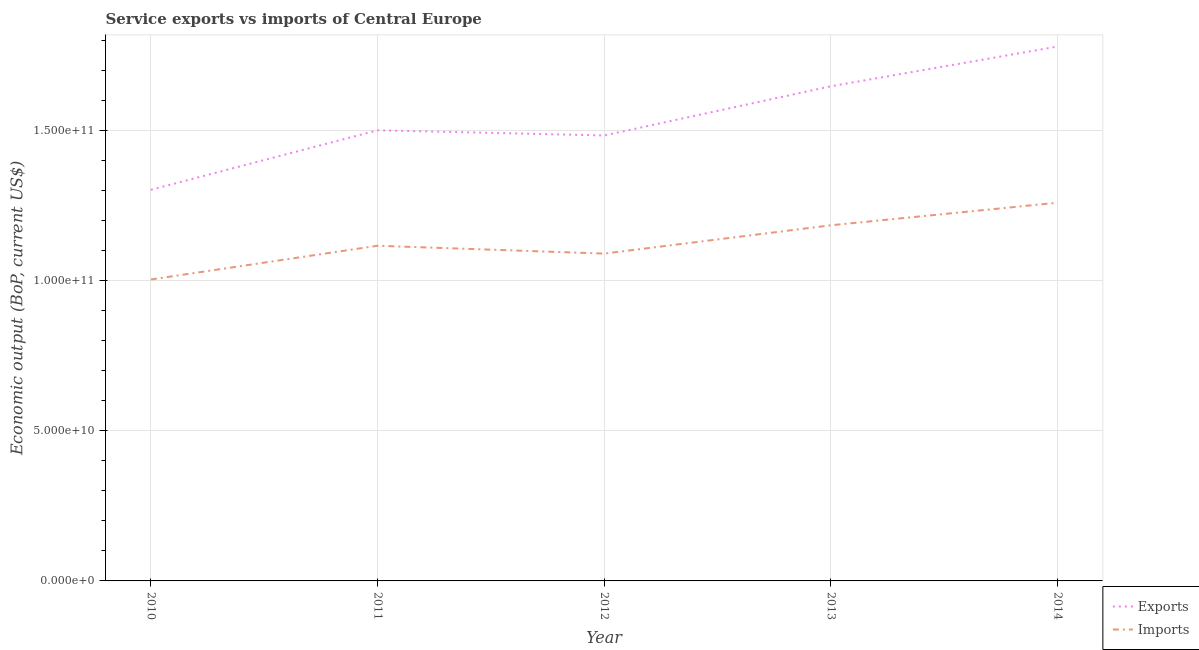Does the line corresponding to amount of service exports intersect with the line corresponding to amount of service imports?
Your response must be concise. No. What is the amount of service exports in 2012?
Make the answer very short. 1.48e+11. Across all years, what is the maximum amount of service imports?
Offer a very short reply. 1.26e+11. Across all years, what is the minimum amount of service exports?
Provide a short and direct response. 1.30e+11. In which year was the amount of service imports maximum?
Provide a short and direct response. 2014. What is the total amount of service exports in the graph?
Keep it short and to the point. 7.71e+11. What is the difference between the amount of service exports in 2012 and that in 2013?
Your answer should be very brief. -1.64e+1. What is the difference between the amount of service imports in 2013 and the amount of service exports in 2010?
Ensure brevity in your answer.  -1.18e+1. What is the average amount of service imports per year?
Make the answer very short. 1.13e+11. In the year 2010, what is the difference between the amount of service exports and amount of service imports?
Make the answer very short. 2.99e+1. In how many years, is the amount of service imports greater than 50000000000 US$?
Your answer should be very brief. 5. What is the ratio of the amount of service exports in 2010 to that in 2011?
Provide a short and direct response. 0.87. What is the difference between the highest and the second highest amount of service exports?
Ensure brevity in your answer.  1.32e+1. What is the difference between the highest and the lowest amount of service exports?
Make the answer very short. 4.77e+1. Is the sum of the amount of service imports in 2010 and 2013 greater than the maximum amount of service exports across all years?
Keep it short and to the point. Yes. How many years are there in the graph?
Your answer should be compact. 5. Are the values on the major ticks of Y-axis written in scientific E-notation?
Offer a terse response. Yes. Where does the legend appear in the graph?
Your answer should be very brief. Bottom right. What is the title of the graph?
Ensure brevity in your answer.  Service exports vs imports of Central Europe. What is the label or title of the X-axis?
Your response must be concise. Year. What is the label or title of the Y-axis?
Offer a terse response. Economic output (BoP, current US$). What is the Economic output (BoP, current US$) of Exports in 2010?
Make the answer very short. 1.30e+11. What is the Economic output (BoP, current US$) in Imports in 2010?
Offer a terse response. 1.00e+11. What is the Economic output (BoP, current US$) in Exports in 2011?
Ensure brevity in your answer.  1.50e+11. What is the Economic output (BoP, current US$) of Imports in 2011?
Provide a succinct answer. 1.12e+11. What is the Economic output (BoP, current US$) in Exports in 2012?
Your response must be concise. 1.48e+11. What is the Economic output (BoP, current US$) in Imports in 2012?
Your response must be concise. 1.09e+11. What is the Economic output (BoP, current US$) of Exports in 2013?
Your answer should be compact. 1.65e+11. What is the Economic output (BoP, current US$) of Imports in 2013?
Offer a terse response. 1.18e+11. What is the Economic output (BoP, current US$) of Exports in 2014?
Make the answer very short. 1.78e+11. What is the Economic output (BoP, current US$) of Imports in 2014?
Your answer should be very brief. 1.26e+11. Across all years, what is the maximum Economic output (BoP, current US$) in Exports?
Your answer should be very brief. 1.78e+11. Across all years, what is the maximum Economic output (BoP, current US$) in Imports?
Provide a succinct answer. 1.26e+11. Across all years, what is the minimum Economic output (BoP, current US$) in Exports?
Offer a very short reply. 1.30e+11. Across all years, what is the minimum Economic output (BoP, current US$) of Imports?
Offer a very short reply. 1.00e+11. What is the total Economic output (BoP, current US$) of Exports in the graph?
Offer a very short reply. 7.71e+11. What is the total Economic output (BoP, current US$) of Imports in the graph?
Make the answer very short. 5.65e+11. What is the difference between the Economic output (BoP, current US$) of Exports in 2010 and that in 2011?
Ensure brevity in your answer.  -1.98e+1. What is the difference between the Economic output (BoP, current US$) of Imports in 2010 and that in 2011?
Give a very brief answer. -1.12e+1. What is the difference between the Economic output (BoP, current US$) in Exports in 2010 and that in 2012?
Provide a succinct answer. -1.81e+1. What is the difference between the Economic output (BoP, current US$) in Imports in 2010 and that in 2012?
Keep it short and to the point. -8.62e+09. What is the difference between the Economic output (BoP, current US$) of Exports in 2010 and that in 2013?
Offer a terse response. -3.45e+1. What is the difference between the Economic output (BoP, current US$) in Imports in 2010 and that in 2013?
Ensure brevity in your answer.  -1.80e+1. What is the difference between the Economic output (BoP, current US$) of Exports in 2010 and that in 2014?
Provide a short and direct response. -4.77e+1. What is the difference between the Economic output (BoP, current US$) in Imports in 2010 and that in 2014?
Ensure brevity in your answer.  -2.56e+1. What is the difference between the Economic output (BoP, current US$) in Exports in 2011 and that in 2012?
Provide a short and direct response. 1.72e+09. What is the difference between the Economic output (BoP, current US$) of Imports in 2011 and that in 2012?
Your response must be concise. 2.61e+09. What is the difference between the Economic output (BoP, current US$) of Exports in 2011 and that in 2013?
Ensure brevity in your answer.  -1.47e+1. What is the difference between the Economic output (BoP, current US$) of Imports in 2011 and that in 2013?
Keep it short and to the point. -6.81e+09. What is the difference between the Economic output (BoP, current US$) of Exports in 2011 and that in 2014?
Your response must be concise. -2.79e+1. What is the difference between the Economic output (BoP, current US$) of Imports in 2011 and that in 2014?
Give a very brief answer. -1.43e+1. What is the difference between the Economic output (BoP, current US$) in Exports in 2012 and that in 2013?
Provide a short and direct response. -1.64e+1. What is the difference between the Economic output (BoP, current US$) of Imports in 2012 and that in 2013?
Keep it short and to the point. -9.42e+09. What is the difference between the Economic output (BoP, current US$) in Exports in 2012 and that in 2014?
Ensure brevity in your answer.  -2.96e+1. What is the difference between the Economic output (BoP, current US$) of Imports in 2012 and that in 2014?
Your answer should be very brief. -1.69e+1. What is the difference between the Economic output (BoP, current US$) in Exports in 2013 and that in 2014?
Ensure brevity in your answer.  -1.32e+1. What is the difference between the Economic output (BoP, current US$) in Imports in 2013 and that in 2014?
Make the answer very short. -7.52e+09. What is the difference between the Economic output (BoP, current US$) in Exports in 2010 and the Economic output (BoP, current US$) in Imports in 2011?
Offer a terse response. 1.86e+1. What is the difference between the Economic output (BoP, current US$) in Exports in 2010 and the Economic output (BoP, current US$) in Imports in 2012?
Make the answer very short. 2.12e+1. What is the difference between the Economic output (BoP, current US$) in Exports in 2010 and the Economic output (BoP, current US$) in Imports in 2013?
Keep it short and to the point. 1.18e+1. What is the difference between the Economic output (BoP, current US$) of Exports in 2010 and the Economic output (BoP, current US$) of Imports in 2014?
Provide a short and direct response. 4.30e+09. What is the difference between the Economic output (BoP, current US$) in Exports in 2011 and the Economic output (BoP, current US$) in Imports in 2012?
Provide a short and direct response. 4.10e+1. What is the difference between the Economic output (BoP, current US$) of Exports in 2011 and the Economic output (BoP, current US$) of Imports in 2013?
Ensure brevity in your answer.  3.16e+1. What is the difference between the Economic output (BoP, current US$) in Exports in 2011 and the Economic output (BoP, current US$) in Imports in 2014?
Your response must be concise. 2.41e+1. What is the difference between the Economic output (BoP, current US$) in Exports in 2012 and the Economic output (BoP, current US$) in Imports in 2013?
Offer a terse response. 2.99e+1. What is the difference between the Economic output (BoP, current US$) of Exports in 2012 and the Economic output (BoP, current US$) of Imports in 2014?
Provide a short and direct response. 2.24e+1. What is the difference between the Economic output (BoP, current US$) of Exports in 2013 and the Economic output (BoP, current US$) of Imports in 2014?
Your answer should be very brief. 3.88e+1. What is the average Economic output (BoP, current US$) of Exports per year?
Ensure brevity in your answer.  1.54e+11. What is the average Economic output (BoP, current US$) in Imports per year?
Provide a succinct answer. 1.13e+11. In the year 2010, what is the difference between the Economic output (BoP, current US$) of Exports and Economic output (BoP, current US$) of Imports?
Give a very brief answer. 2.99e+1. In the year 2011, what is the difference between the Economic output (BoP, current US$) of Exports and Economic output (BoP, current US$) of Imports?
Your answer should be compact. 3.84e+1. In the year 2012, what is the difference between the Economic output (BoP, current US$) in Exports and Economic output (BoP, current US$) in Imports?
Give a very brief answer. 3.93e+1. In the year 2013, what is the difference between the Economic output (BoP, current US$) of Exports and Economic output (BoP, current US$) of Imports?
Your answer should be compact. 4.63e+1. In the year 2014, what is the difference between the Economic output (BoP, current US$) of Exports and Economic output (BoP, current US$) of Imports?
Make the answer very short. 5.20e+1. What is the ratio of the Economic output (BoP, current US$) of Exports in 2010 to that in 2011?
Provide a short and direct response. 0.87. What is the ratio of the Economic output (BoP, current US$) of Imports in 2010 to that in 2011?
Provide a succinct answer. 0.9. What is the ratio of the Economic output (BoP, current US$) in Exports in 2010 to that in 2012?
Your response must be concise. 0.88. What is the ratio of the Economic output (BoP, current US$) in Imports in 2010 to that in 2012?
Keep it short and to the point. 0.92. What is the ratio of the Economic output (BoP, current US$) in Exports in 2010 to that in 2013?
Your answer should be very brief. 0.79. What is the ratio of the Economic output (BoP, current US$) in Imports in 2010 to that in 2013?
Your answer should be very brief. 0.85. What is the ratio of the Economic output (BoP, current US$) of Exports in 2010 to that in 2014?
Your answer should be very brief. 0.73. What is the ratio of the Economic output (BoP, current US$) of Imports in 2010 to that in 2014?
Your response must be concise. 0.8. What is the ratio of the Economic output (BoP, current US$) of Exports in 2011 to that in 2012?
Offer a very short reply. 1.01. What is the ratio of the Economic output (BoP, current US$) in Imports in 2011 to that in 2012?
Your answer should be compact. 1.02. What is the ratio of the Economic output (BoP, current US$) in Exports in 2011 to that in 2013?
Offer a very short reply. 0.91. What is the ratio of the Economic output (BoP, current US$) of Imports in 2011 to that in 2013?
Offer a terse response. 0.94. What is the ratio of the Economic output (BoP, current US$) in Exports in 2011 to that in 2014?
Your answer should be compact. 0.84. What is the ratio of the Economic output (BoP, current US$) in Imports in 2011 to that in 2014?
Offer a very short reply. 0.89. What is the ratio of the Economic output (BoP, current US$) of Exports in 2012 to that in 2013?
Your answer should be very brief. 0.9. What is the ratio of the Economic output (BoP, current US$) of Imports in 2012 to that in 2013?
Your answer should be very brief. 0.92. What is the ratio of the Economic output (BoP, current US$) in Exports in 2012 to that in 2014?
Your answer should be compact. 0.83. What is the ratio of the Economic output (BoP, current US$) in Imports in 2012 to that in 2014?
Offer a terse response. 0.87. What is the ratio of the Economic output (BoP, current US$) in Exports in 2013 to that in 2014?
Your answer should be compact. 0.93. What is the ratio of the Economic output (BoP, current US$) in Imports in 2013 to that in 2014?
Make the answer very short. 0.94. What is the difference between the highest and the second highest Economic output (BoP, current US$) of Exports?
Your answer should be very brief. 1.32e+1. What is the difference between the highest and the second highest Economic output (BoP, current US$) in Imports?
Provide a short and direct response. 7.52e+09. What is the difference between the highest and the lowest Economic output (BoP, current US$) in Exports?
Offer a very short reply. 4.77e+1. What is the difference between the highest and the lowest Economic output (BoP, current US$) of Imports?
Offer a very short reply. 2.56e+1. 